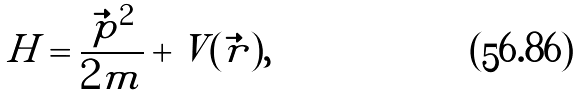Convert formula to latex. <formula><loc_0><loc_0><loc_500><loc_500>H = \frac { { \vec { p } } ^ { 2 } } { 2 m } + V ( { \vec { r } } ) ,</formula> 